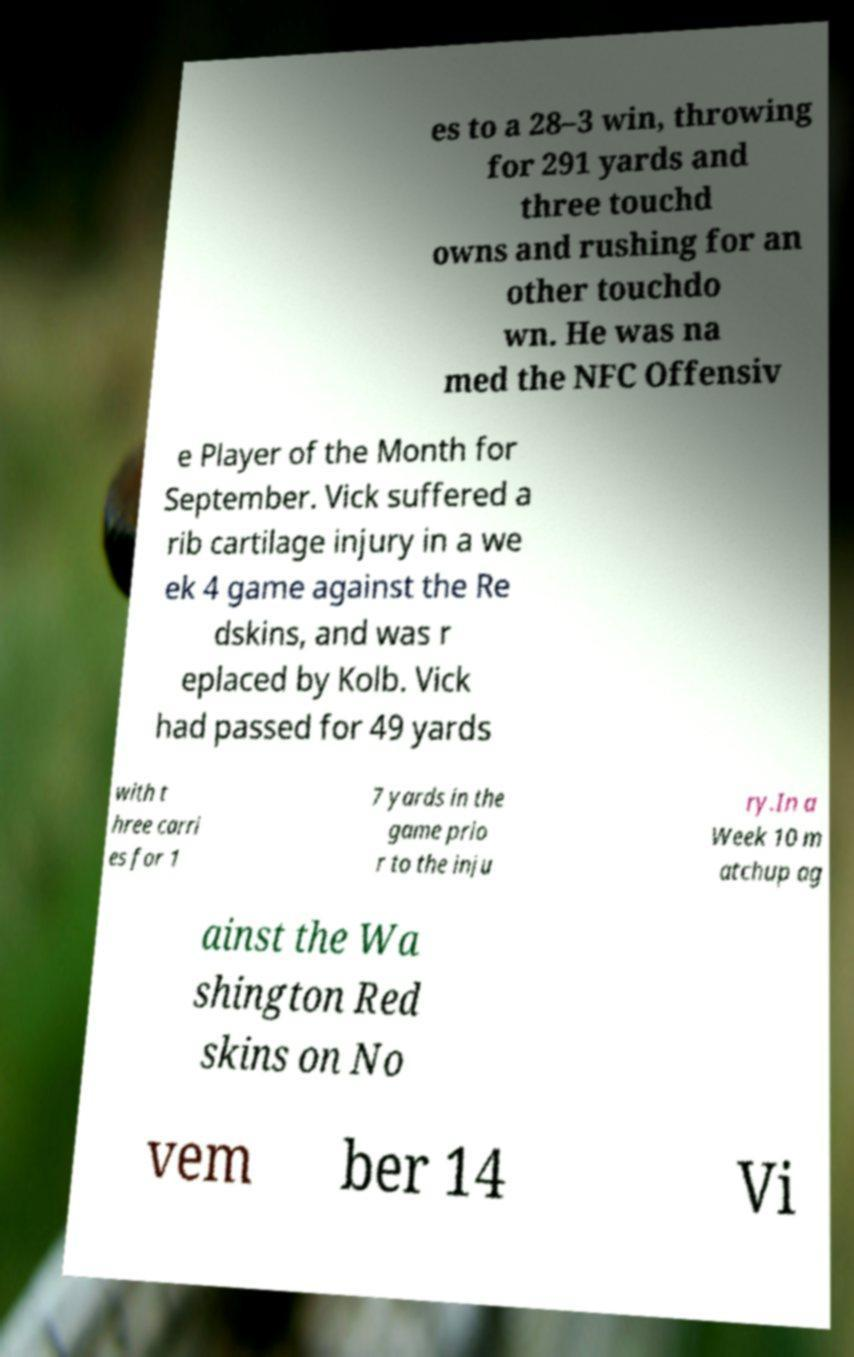Can you accurately transcribe the text from the provided image for me? es to a 28–3 win, throwing for 291 yards and three touchd owns and rushing for an other touchdo wn. He was na med the NFC Offensiv e Player of the Month for September. Vick suffered a rib cartilage injury in a we ek 4 game against the Re dskins, and was r eplaced by Kolb. Vick had passed for 49 yards with t hree carri es for 1 7 yards in the game prio r to the inju ry.In a Week 10 m atchup ag ainst the Wa shington Red skins on No vem ber 14 Vi 